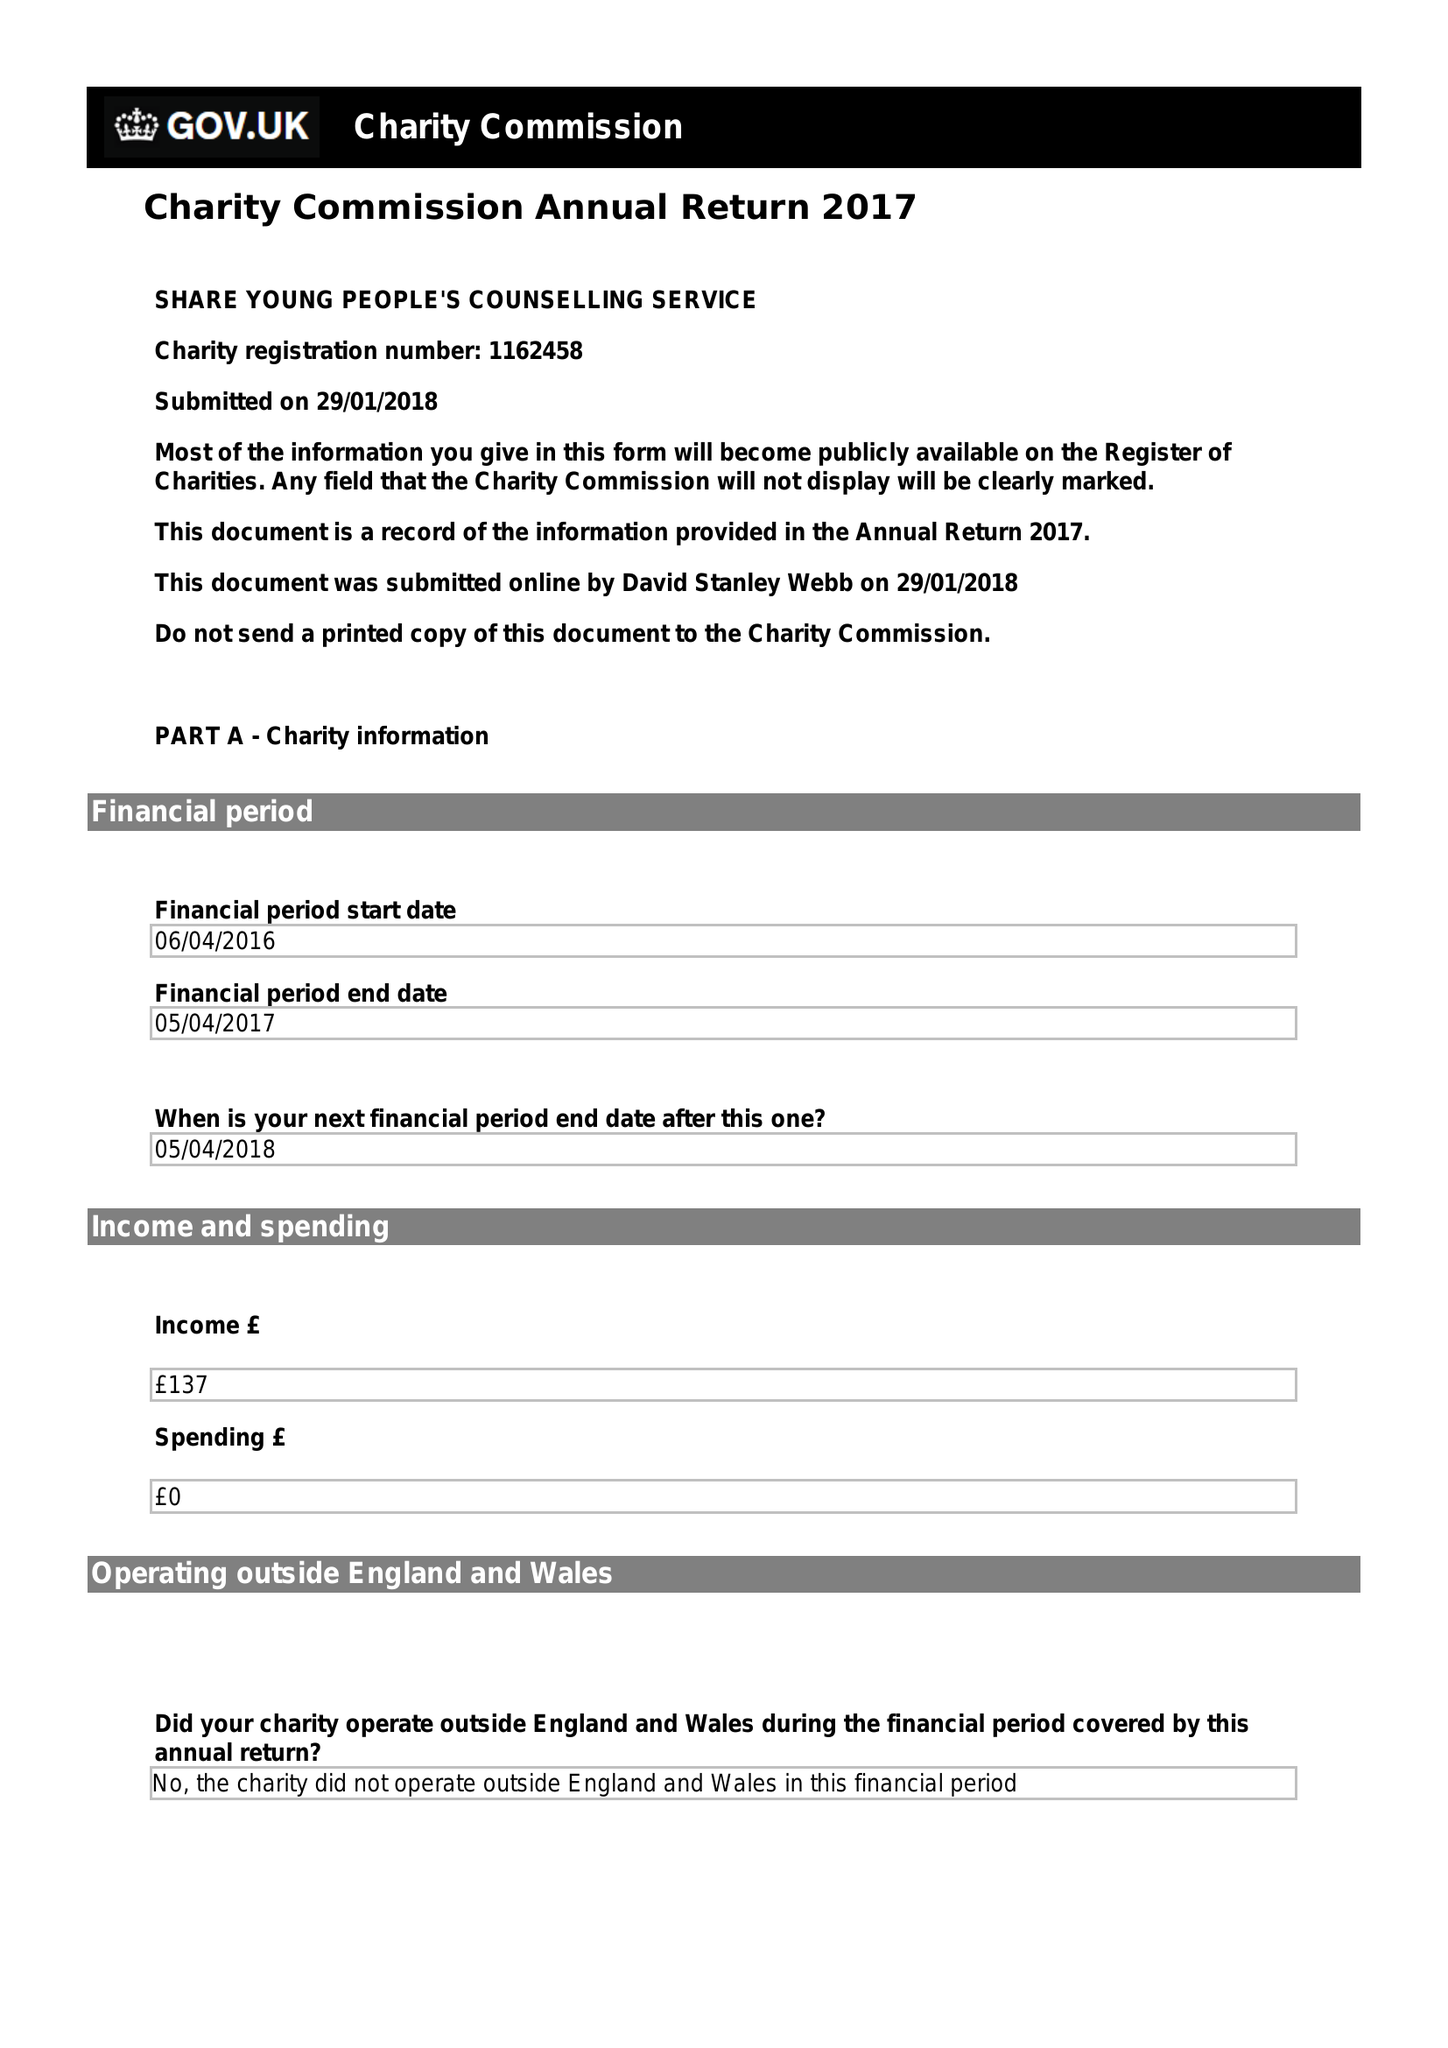What is the value for the address__street_line?
Answer the question using a single word or phrase. 113A CLYDE CRESCENT 